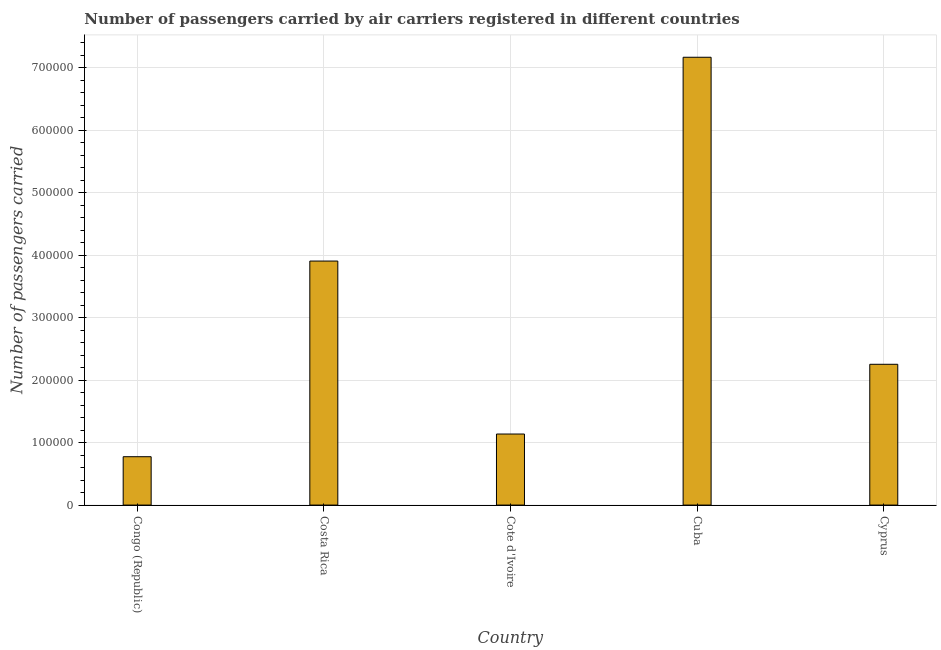Does the graph contain grids?
Your answer should be compact. Yes. What is the title of the graph?
Give a very brief answer. Number of passengers carried by air carriers registered in different countries. What is the label or title of the Y-axis?
Your answer should be very brief. Number of passengers carried. What is the number of passengers carried in Cyprus?
Give a very brief answer. 2.25e+05. Across all countries, what is the maximum number of passengers carried?
Provide a short and direct response. 7.17e+05. Across all countries, what is the minimum number of passengers carried?
Provide a succinct answer. 7.74e+04. In which country was the number of passengers carried maximum?
Your answer should be very brief. Cuba. In which country was the number of passengers carried minimum?
Make the answer very short. Congo (Republic). What is the sum of the number of passengers carried?
Your response must be concise. 1.52e+06. What is the difference between the number of passengers carried in Cuba and Cyprus?
Your response must be concise. 4.91e+05. What is the average number of passengers carried per country?
Make the answer very short. 3.05e+05. What is the median number of passengers carried?
Your response must be concise. 2.25e+05. In how many countries, is the number of passengers carried greater than 100000 ?
Make the answer very short. 4. What is the ratio of the number of passengers carried in Congo (Republic) to that in Cyprus?
Provide a short and direct response. 0.34. What is the difference between the highest and the second highest number of passengers carried?
Your answer should be very brief. 3.26e+05. Is the sum of the number of passengers carried in Cuba and Cyprus greater than the maximum number of passengers carried across all countries?
Offer a terse response. Yes. What is the difference between the highest and the lowest number of passengers carried?
Keep it short and to the point. 6.39e+05. In how many countries, is the number of passengers carried greater than the average number of passengers carried taken over all countries?
Offer a terse response. 2. Are all the bars in the graph horizontal?
Your answer should be very brief. No. How many countries are there in the graph?
Give a very brief answer. 5. What is the difference between two consecutive major ticks on the Y-axis?
Your answer should be very brief. 1.00e+05. What is the Number of passengers carried of Congo (Republic)?
Keep it short and to the point. 7.74e+04. What is the Number of passengers carried of Costa Rica?
Your response must be concise. 3.90e+05. What is the Number of passengers carried of Cote d'Ivoire?
Ensure brevity in your answer.  1.14e+05. What is the Number of passengers carried of Cuba?
Provide a succinct answer. 7.17e+05. What is the Number of passengers carried in Cyprus?
Keep it short and to the point. 2.25e+05. What is the difference between the Number of passengers carried in Congo (Republic) and Costa Rica?
Give a very brief answer. -3.13e+05. What is the difference between the Number of passengers carried in Congo (Republic) and Cote d'Ivoire?
Offer a terse response. -3.63e+04. What is the difference between the Number of passengers carried in Congo (Republic) and Cuba?
Keep it short and to the point. -6.39e+05. What is the difference between the Number of passengers carried in Congo (Republic) and Cyprus?
Ensure brevity in your answer.  -1.48e+05. What is the difference between the Number of passengers carried in Costa Rica and Cote d'Ivoire?
Ensure brevity in your answer.  2.77e+05. What is the difference between the Number of passengers carried in Costa Rica and Cuba?
Keep it short and to the point. -3.26e+05. What is the difference between the Number of passengers carried in Costa Rica and Cyprus?
Offer a terse response. 1.65e+05. What is the difference between the Number of passengers carried in Cote d'Ivoire and Cuba?
Keep it short and to the point. -6.03e+05. What is the difference between the Number of passengers carried in Cote d'Ivoire and Cyprus?
Offer a very short reply. -1.12e+05. What is the difference between the Number of passengers carried in Cuba and Cyprus?
Provide a short and direct response. 4.91e+05. What is the ratio of the Number of passengers carried in Congo (Republic) to that in Costa Rica?
Provide a succinct answer. 0.2. What is the ratio of the Number of passengers carried in Congo (Republic) to that in Cote d'Ivoire?
Your answer should be compact. 0.68. What is the ratio of the Number of passengers carried in Congo (Republic) to that in Cuba?
Offer a very short reply. 0.11. What is the ratio of the Number of passengers carried in Congo (Republic) to that in Cyprus?
Give a very brief answer. 0.34. What is the ratio of the Number of passengers carried in Costa Rica to that in Cote d'Ivoire?
Make the answer very short. 3.43. What is the ratio of the Number of passengers carried in Costa Rica to that in Cuba?
Provide a short and direct response. 0.55. What is the ratio of the Number of passengers carried in Costa Rica to that in Cyprus?
Your answer should be very brief. 1.73. What is the ratio of the Number of passengers carried in Cote d'Ivoire to that in Cuba?
Offer a terse response. 0.16. What is the ratio of the Number of passengers carried in Cote d'Ivoire to that in Cyprus?
Your answer should be very brief. 0.51. What is the ratio of the Number of passengers carried in Cuba to that in Cyprus?
Provide a succinct answer. 3.18. 